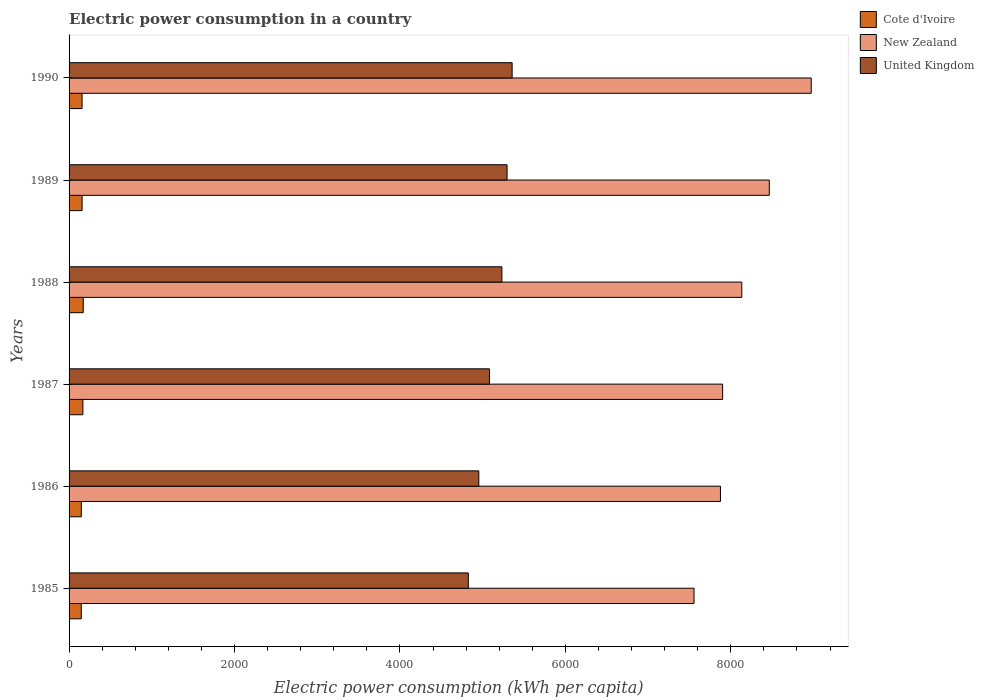How many groups of bars are there?
Offer a terse response. 6. How many bars are there on the 6th tick from the top?
Ensure brevity in your answer.  3. What is the electric power consumption in in United Kingdom in 1987?
Your answer should be compact. 5082.44. Across all years, what is the maximum electric power consumption in in New Zealand?
Your answer should be compact. 8972.31. Across all years, what is the minimum electric power consumption in in United Kingdom?
Ensure brevity in your answer.  4826.71. What is the total electric power consumption in in New Zealand in the graph?
Your answer should be very brief. 4.89e+04. What is the difference between the electric power consumption in in United Kingdom in 1985 and that in 1990?
Offer a terse response. -529.86. What is the difference between the electric power consumption in in New Zealand in 1987 and the electric power consumption in in United Kingdom in 1986?
Make the answer very short. 2947.64. What is the average electric power consumption in in United Kingdom per year?
Your answer should be compact. 5124.56. In the year 1985, what is the difference between the electric power consumption in in New Zealand and electric power consumption in in United Kingdom?
Your answer should be compact. 2728.95. What is the ratio of the electric power consumption in in New Zealand in 1986 to that in 1987?
Your response must be concise. 1. Is the electric power consumption in in Cote d'Ivoire in 1987 less than that in 1990?
Provide a succinct answer. No. What is the difference between the highest and the second highest electric power consumption in in United Kingdom?
Your answer should be very brief. 61.35. What is the difference between the highest and the lowest electric power consumption in in Cote d'Ivoire?
Give a very brief answer. 23.64. In how many years, is the electric power consumption in in United Kingdom greater than the average electric power consumption in in United Kingdom taken over all years?
Ensure brevity in your answer.  3. What does the 3rd bar from the top in 1990 represents?
Make the answer very short. Cote d'Ivoire. Is it the case that in every year, the sum of the electric power consumption in in United Kingdom and electric power consumption in in New Zealand is greater than the electric power consumption in in Cote d'Ivoire?
Provide a succinct answer. Yes. Are the values on the major ticks of X-axis written in scientific E-notation?
Provide a succinct answer. No. Does the graph contain any zero values?
Offer a very short reply. No. Does the graph contain grids?
Your answer should be very brief. No. Where does the legend appear in the graph?
Offer a terse response. Top right. How many legend labels are there?
Offer a terse response. 3. How are the legend labels stacked?
Ensure brevity in your answer.  Vertical. What is the title of the graph?
Give a very brief answer. Electric power consumption in a country. What is the label or title of the X-axis?
Keep it short and to the point. Electric power consumption (kWh per capita). What is the label or title of the Y-axis?
Your answer should be very brief. Years. What is the Electric power consumption (kWh per capita) of Cote d'Ivoire in 1985?
Keep it short and to the point. 147.57. What is the Electric power consumption (kWh per capita) of New Zealand in 1985?
Your response must be concise. 7555.67. What is the Electric power consumption (kWh per capita) of United Kingdom in 1985?
Provide a short and direct response. 4826.71. What is the Electric power consumption (kWh per capita) in Cote d'Ivoire in 1986?
Give a very brief answer. 148.18. What is the Electric power consumption (kWh per capita) of New Zealand in 1986?
Your response must be concise. 7875.12. What is the Electric power consumption (kWh per capita) in United Kingdom in 1986?
Offer a very short reply. 4953.65. What is the Electric power consumption (kWh per capita) of Cote d'Ivoire in 1987?
Provide a short and direct response. 166.82. What is the Electric power consumption (kWh per capita) in New Zealand in 1987?
Make the answer very short. 7901.29. What is the Electric power consumption (kWh per capita) in United Kingdom in 1987?
Provide a short and direct response. 5082.44. What is the Electric power consumption (kWh per capita) of Cote d'Ivoire in 1988?
Offer a terse response. 171.21. What is the Electric power consumption (kWh per capita) in New Zealand in 1988?
Provide a short and direct response. 8133.03. What is the Electric power consumption (kWh per capita) of United Kingdom in 1988?
Your response must be concise. 5232.74. What is the Electric power consumption (kWh per capita) in Cote d'Ivoire in 1989?
Make the answer very short. 157.43. What is the Electric power consumption (kWh per capita) of New Zealand in 1989?
Make the answer very short. 8465.39. What is the Electric power consumption (kWh per capita) of United Kingdom in 1989?
Keep it short and to the point. 5295.22. What is the Electric power consumption (kWh per capita) of Cote d'Ivoire in 1990?
Offer a terse response. 157.24. What is the Electric power consumption (kWh per capita) in New Zealand in 1990?
Give a very brief answer. 8972.31. What is the Electric power consumption (kWh per capita) of United Kingdom in 1990?
Make the answer very short. 5356.58. Across all years, what is the maximum Electric power consumption (kWh per capita) of Cote d'Ivoire?
Make the answer very short. 171.21. Across all years, what is the maximum Electric power consumption (kWh per capita) of New Zealand?
Offer a terse response. 8972.31. Across all years, what is the maximum Electric power consumption (kWh per capita) in United Kingdom?
Give a very brief answer. 5356.58. Across all years, what is the minimum Electric power consumption (kWh per capita) in Cote d'Ivoire?
Give a very brief answer. 147.57. Across all years, what is the minimum Electric power consumption (kWh per capita) of New Zealand?
Offer a terse response. 7555.67. Across all years, what is the minimum Electric power consumption (kWh per capita) of United Kingdom?
Provide a short and direct response. 4826.71. What is the total Electric power consumption (kWh per capita) in Cote d'Ivoire in the graph?
Keep it short and to the point. 948.45. What is the total Electric power consumption (kWh per capita) of New Zealand in the graph?
Ensure brevity in your answer.  4.89e+04. What is the total Electric power consumption (kWh per capita) in United Kingdom in the graph?
Ensure brevity in your answer.  3.07e+04. What is the difference between the Electric power consumption (kWh per capita) of Cote d'Ivoire in 1985 and that in 1986?
Provide a succinct answer. -0.61. What is the difference between the Electric power consumption (kWh per capita) in New Zealand in 1985 and that in 1986?
Offer a very short reply. -319.45. What is the difference between the Electric power consumption (kWh per capita) of United Kingdom in 1985 and that in 1986?
Keep it short and to the point. -126.94. What is the difference between the Electric power consumption (kWh per capita) in Cote d'Ivoire in 1985 and that in 1987?
Make the answer very short. -19.25. What is the difference between the Electric power consumption (kWh per capita) in New Zealand in 1985 and that in 1987?
Your response must be concise. -345.63. What is the difference between the Electric power consumption (kWh per capita) of United Kingdom in 1985 and that in 1987?
Make the answer very short. -255.73. What is the difference between the Electric power consumption (kWh per capita) in Cote d'Ivoire in 1985 and that in 1988?
Offer a terse response. -23.64. What is the difference between the Electric power consumption (kWh per capita) of New Zealand in 1985 and that in 1988?
Provide a short and direct response. -577.37. What is the difference between the Electric power consumption (kWh per capita) in United Kingdom in 1985 and that in 1988?
Make the answer very short. -406.02. What is the difference between the Electric power consumption (kWh per capita) in Cote d'Ivoire in 1985 and that in 1989?
Your answer should be very brief. -9.86. What is the difference between the Electric power consumption (kWh per capita) of New Zealand in 1985 and that in 1989?
Provide a short and direct response. -909.72. What is the difference between the Electric power consumption (kWh per capita) in United Kingdom in 1985 and that in 1989?
Your response must be concise. -468.51. What is the difference between the Electric power consumption (kWh per capita) of Cote d'Ivoire in 1985 and that in 1990?
Keep it short and to the point. -9.67. What is the difference between the Electric power consumption (kWh per capita) of New Zealand in 1985 and that in 1990?
Give a very brief answer. -1416.65. What is the difference between the Electric power consumption (kWh per capita) of United Kingdom in 1985 and that in 1990?
Your answer should be compact. -529.86. What is the difference between the Electric power consumption (kWh per capita) of Cote d'Ivoire in 1986 and that in 1987?
Ensure brevity in your answer.  -18.64. What is the difference between the Electric power consumption (kWh per capita) of New Zealand in 1986 and that in 1987?
Your response must be concise. -26.18. What is the difference between the Electric power consumption (kWh per capita) in United Kingdom in 1986 and that in 1987?
Give a very brief answer. -128.79. What is the difference between the Electric power consumption (kWh per capita) of Cote d'Ivoire in 1986 and that in 1988?
Give a very brief answer. -23.03. What is the difference between the Electric power consumption (kWh per capita) of New Zealand in 1986 and that in 1988?
Provide a succinct answer. -257.91. What is the difference between the Electric power consumption (kWh per capita) of United Kingdom in 1986 and that in 1988?
Give a very brief answer. -279.08. What is the difference between the Electric power consumption (kWh per capita) in Cote d'Ivoire in 1986 and that in 1989?
Offer a terse response. -9.26. What is the difference between the Electric power consumption (kWh per capita) of New Zealand in 1986 and that in 1989?
Your answer should be compact. -590.27. What is the difference between the Electric power consumption (kWh per capita) in United Kingdom in 1986 and that in 1989?
Your answer should be very brief. -341.57. What is the difference between the Electric power consumption (kWh per capita) in Cote d'Ivoire in 1986 and that in 1990?
Provide a short and direct response. -9.06. What is the difference between the Electric power consumption (kWh per capita) in New Zealand in 1986 and that in 1990?
Keep it short and to the point. -1097.19. What is the difference between the Electric power consumption (kWh per capita) in United Kingdom in 1986 and that in 1990?
Ensure brevity in your answer.  -402.92. What is the difference between the Electric power consumption (kWh per capita) in Cote d'Ivoire in 1987 and that in 1988?
Provide a succinct answer. -4.39. What is the difference between the Electric power consumption (kWh per capita) of New Zealand in 1987 and that in 1988?
Make the answer very short. -231.74. What is the difference between the Electric power consumption (kWh per capita) in United Kingdom in 1987 and that in 1988?
Your answer should be compact. -150.3. What is the difference between the Electric power consumption (kWh per capita) of Cote d'Ivoire in 1987 and that in 1989?
Give a very brief answer. 9.39. What is the difference between the Electric power consumption (kWh per capita) in New Zealand in 1987 and that in 1989?
Offer a terse response. -564.09. What is the difference between the Electric power consumption (kWh per capita) in United Kingdom in 1987 and that in 1989?
Make the answer very short. -212.78. What is the difference between the Electric power consumption (kWh per capita) in Cote d'Ivoire in 1987 and that in 1990?
Your answer should be very brief. 9.58. What is the difference between the Electric power consumption (kWh per capita) in New Zealand in 1987 and that in 1990?
Provide a short and direct response. -1071.02. What is the difference between the Electric power consumption (kWh per capita) in United Kingdom in 1987 and that in 1990?
Make the answer very short. -274.14. What is the difference between the Electric power consumption (kWh per capita) of Cote d'Ivoire in 1988 and that in 1989?
Keep it short and to the point. 13.77. What is the difference between the Electric power consumption (kWh per capita) of New Zealand in 1988 and that in 1989?
Make the answer very short. -332.35. What is the difference between the Electric power consumption (kWh per capita) in United Kingdom in 1988 and that in 1989?
Your answer should be compact. -62.49. What is the difference between the Electric power consumption (kWh per capita) of Cote d'Ivoire in 1988 and that in 1990?
Provide a short and direct response. 13.96. What is the difference between the Electric power consumption (kWh per capita) of New Zealand in 1988 and that in 1990?
Offer a terse response. -839.28. What is the difference between the Electric power consumption (kWh per capita) in United Kingdom in 1988 and that in 1990?
Ensure brevity in your answer.  -123.84. What is the difference between the Electric power consumption (kWh per capita) of Cote d'Ivoire in 1989 and that in 1990?
Make the answer very short. 0.19. What is the difference between the Electric power consumption (kWh per capita) of New Zealand in 1989 and that in 1990?
Make the answer very short. -506.93. What is the difference between the Electric power consumption (kWh per capita) in United Kingdom in 1989 and that in 1990?
Keep it short and to the point. -61.35. What is the difference between the Electric power consumption (kWh per capita) of Cote d'Ivoire in 1985 and the Electric power consumption (kWh per capita) of New Zealand in 1986?
Your answer should be very brief. -7727.55. What is the difference between the Electric power consumption (kWh per capita) of Cote d'Ivoire in 1985 and the Electric power consumption (kWh per capita) of United Kingdom in 1986?
Provide a short and direct response. -4806.09. What is the difference between the Electric power consumption (kWh per capita) in New Zealand in 1985 and the Electric power consumption (kWh per capita) in United Kingdom in 1986?
Your response must be concise. 2602.01. What is the difference between the Electric power consumption (kWh per capita) in Cote d'Ivoire in 1985 and the Electric power consumption (kWh per capita) in New Zealand in 1987?
Provide a succinct answer. -7753.73. What is the difference between the Electric power consumption (kWh per capita) in Cote d'Ivoire in 1985 and the Electric power consumption (kWh per capita) in United Kingdom in 1987?
Your answer should be very brief. -4934.87. What is the difference between the Electric power consumption (kWh per capita) in New Zealand in 1985 and the Electric power consumption (kWh per capita) in United Kingdom in 1987?
Give a very brief answer. 2473.23. What is the difference between the Electric power consumption (kWh per capita) of Cote d'Ivoire in 1985 and the Electric power consumption (kWh per capita) of New Zealand in 1988?
Offer a very short reply. -7985.46. What is the difference between the Electric power consumption (kWh per capita) in Cote d'Ivoire in 1985 and the Electric power consumption (kWh per capita) in United Kingdom in 1988?
Your response must be concise. -5085.17. What is the difference between the Electric power consumption (kWh per capita) in New Zealand in 1985 and the Electric power consumption (kWh per capita) in United Kingdom in 1988?
Your answer should be compact. 2322.93. What is the difference between the Electric power consumption (kWh per capita) in Cote d'Ivoire in 1985 and the Electric power consumption (kWh per capita) in New Zealand in 1989?
Keep it short and to the point. -8317.82. What is the difference between the Electric power consumption (kWh per capita) in Cote d'Ivoire in 1985 and the Electric power consumption (kWh per capita) in United Kingdom in 1989?
Offer a terse response. -5147.66. What is the difference between the Electric power consumption (kWh per capita) in New Zealand in 1985 and the Electric power consumption (kWh per capita) in United Kingdom in 1989?
Offer a very short reply. 2260.44. What is the difference between the Electric power consumption (kWh per capita) in Cote d'Ivoire in 1985 and the Electric power consumption (kWh per capita) in New Zealand in 1990?
Make the answer very short. -8824.74. What is the difference between the Electric power consumption (kWh per capita) in Cote d'Ivoire in 1985 and the Electric power consumption (kWh per capita) in United Kingdom in 1990?
Provide a succinct answer. -5209.01. What is the difference between the Electric power consumption (kWh per capita) in New Zealand in 1985 and the Electric power consumption (kWh per capita) in United Kingdom in 1990?
Your answer should be very brief. 2199.09. What is the difference between the Electric power consumption (kWh per capita) of Cote d'Ivoire in 1986 and the Electric power consumption (kWh per capita) of New Zealand in 1987?
Provide a succinct answer. -7753.12. What is the difference between the Electric power consumption (kWh per capita) in Cote d'Ivoire in 1986 and the Electric power consumption (kWh per capita) in United Kingdom in 1987?
Provide a succinct answer. -4934.26. What is the difference between the Electric power consumption (kWh per capita) in New Zealand in 1986 and the Electric power consumption (kWh per capita) in United Kingdom in 1987?
Offer a terse response. 2792.68. What is the difference between the Electric power consumption (kWh per capita) of Cote d'Ivoire in 1986 and the Electric power consumption (kWh per capita) of New Zealand in 1988?
Give a very brief answer. -7984.86. What is the difference between the Electric power consumption (kWh per capita) of Cote d'Ivoire in 1986 and the Electric power consumption (kWh per capita) of United Kingdom in 1988?
Provide a short and direct response. -5084.56. What is the difference between the Electric power consumption (kWh per capita) of New Zealand in 1986 and the Electric power consumption (kWh per capita) of United Kingdom in 1988?
Your answer should be very brief. 2642.38. What is the difference between the Electric power consumption (kWh per capita) of Cote d'Ivoire in 1986 and the Electric power consumption (kWh per capita) of New Zealand in 1989?
Your answer should be very brief. -8317.21. What is the difference between the Electric power consumption (kWh per capita) of Cote d'Ivoire in 1986 and the Electric power consumption (kWh per capita) of United Kingdom in 1989?
Give a very brief answer. -5147.05. What is the difference between the Electric power consumption (kWh per capita) in New Zealand in 1986 and the Electric power consumption (kWh per capita) in United Kingdom in 1989?
Offer a terse response. 2579.89. What is the difference between the Electric power consumption (kWh per capita) of Cote d'Ivoire in 1986 and the Electric power consumption (kWh per capita) of New Zealand in 1990?
Your response must be concise. -8824.13. What is the difference between the Electric power consumption (kWh per capita) of Cote d'Ivoire in 1986 and the Electric power consumption (kWh per capita) of United Kingdom in 1990?
Offer a terse response. -5208.4. What is the difference between the Electric power consumption (kWh per capita) of New Zealand in 1986 and the Electric power consumption (kWh per capita) of United Kingdom in 1990?
Keep it short and to the point. 2518.54. What is the difference between the Electric power consumption (kWh per capita) in Cote d'Ivoire in 1987 and the Electric power consumption (kWh per capita) in New Zealand in 1988?
Keep it short and to the point. -7966.21. What is the difference between the Electric power consumption (kWh per capita) of Cote d'Ivoire in 1987 and the Electric power consumption (kWh per capita) of United Kingdom in 1988?
Your answer should be very brief. -5065.92. What is the difference between the Electric power consumption (kWh per capita) in New Zealand in 1987 and the Electric power consumption (kWh per capita) in United Kingdom in 1988?
Your answer should be compact. 2668.56. What is the difference between the Electric power consumption (kWh per capita) in Cote d'Ivoire in 1987 and the Electric power consumption (kWh per capita) in New Zealand in 1989?
Ensure brevity in your answer.  -8298.57. What is the difference between the Electric power consumption (kWh per capita) in Cote d'Ivoire in 1987 and the Electric power consumption (kWh per capita) in United Kingdom in 1989?
Make the answer very short. -5128.41. What is the difference between the Electric power consumption (kWh per capita) of New Zealand in 1987 and the Electric power consumption (kWh per capita) of United Kingdom in 1989?
Ensure brevity in your answer.  2606.07. What is the difference between the Electric power consumption (kWh per capita) of Cote d'Ivoire in 1987 and the Electric power consumption (kWh per capita) of New Zealand in 1990?
Your response must be concise. -8805.49. What is the difference between the Electric power consumption (kWh per capita) in Cote d'Ivoire in 1987 and the Electric power consumption (kWh per capita) in United Kingdom in 1990?
Offer a terse response. -5189.76. What is the difference between the Electric power consumption (kWh per capita) of New Zealand in 1987 and the Electric power consumption (kWh per capita) of United Kingdom in 1990?
Your response must be concise. 2544.72. What is the difference between the Electric power consumption (kWh per capita) in Cote d'Ivoire in 1988 and the Electric power consumption (kWh per capita) in New Zealand in 1989?
Keep it short and to the point. -8294.18. What is the difference between the Electric power consumption (kWh per capita) in Cote d'Ivoire in 1988 and the Electric power consumption (kWh per capita) in United Kingdom in 1989?
Make the answer very short. -5124.02. What is the difference between the Electric power consumption (kWh per capita) in New Zealand in 1988 and the Electric power consumption (kWh per capita) in United Kingdom in 1989?
Ensure brevity in your answer.  2837.81. What is the difference between the Electric power consumption (kWh per capita) in Cote d'Ivoire in 1988 and the Electric power consumption (kWh per capita) in New Zealand in 1990?
Offer a terse response. -8801.1. What is the difference between the Electric power consumption (kWh per capita) in Cote d'Ivoire in 1988 and the Electric power consumption (kWh per capita) in United Kingdom in 1990?
Ensure brevity in your answer.  -5185.37. What is the difference between the Electric power consumption (kWh per capita) in New Zealand in 1988 and the Electric power consumption (kWh per capita) in United Kingdom in 1990?
Provide a short and direct response. 2776.46. What is the difference between the Electric power consumption (kWh per capita) of Cote d'Ivoire in 1989 and the Electric power consumption (kWh per capita) of New Zealand in 1990?
Your answer should be compact. -8814.88. What is the difference between the Electric power consumption (kWh per capita) in Cote d'Ivoire in 1989 and the Electric power consumption (kWh per capita) in United Kingdom in 1990?
Your answer should be compact. -5199.14. What is the difference between the Electric power consumption (kWh per capita) of New Zealand in 1989 and the Electric power consumption (kWh per capita) of United Kingdom in 1990?
Your answer should be very brief. 3108.81. What is the average Electric power consumption (kWh per capita) of Cote d'Ivoire per year?
Keep it short and to the point. 158.07. What is the average Electric power consumption (kWh per capita) of New Zealand per year?
Make the answer very short. 8150.47. What is the average Electric power consumption (kWh per capita) of United Kingdom per year?
Offer a terse response. 5124.56. In the year 1985, what is the difference between the Electric power consumption (kWh per capita) in Cote d'Ivoire and Electric power consumption (kWh per capita) in New Zealand?
Provide a succinct answer. -7408.1. In the year 1985, what is the difference between the Electric power consumption (kWh per capita) of Cote d'Ivoire and Electric power consumption (kWh per capita) of United Kingdom?
Offer a very short reply. -4679.15. In the year 1985, what is the difference between the Electric power consumption (kWh per capita) in New Zealand and Electric power consumption (kWh per capita) in United Kingdom?
Offer a very short reply. 2728.95. In the year 1986, what is the difference between the Electric power consumption (kWh per capita) of Cote d'Ivoire and Electric power consumption (kWh per capita) of New Zealand?
Offer a very short reply. -7726.94. In the year 1986, what is the difference between the Electric power consumption (kWh per capita) of Cote d'Ivoire and Electric power consumption (kWh per capita) of United Kingdom?
Keep it short and to the point. -4805.48. In the year 1986, what is the difference between the Electric power consumption (kWh per capita) of New Zealand and Electric power consumption (kWh per capita) of United Kingdom?
Make the answer very short. 2921.47. In the year 1987, what is the difference between the Electric power consumption (kWh per capita) in Cote d'Ivoire and Electric power consumption (kWh per capita) in New Zealand?
Make the answer very short. -7734.48. In the year 1987, what is the difference between the Electric power consumption (kWh per capita) in Cote d'Ivoire and Electric power consumption (kWh per capita) in United Kingdom?
Provide a short and direct response. -4915.62. In the year 1987, what is the difference between the Electric power consumption (kWh per capita) in New Zealand and Electric power consumption (kWh per capita) in United Kingdom?
Make the answer very short. 2818.86. In the year 1988, what is the difference between the Electric power consumption (kWh per capita) in Cote d'Ivoire and Electric power consumption (kWh per capita) in New Zealand?
Provide a short and direct response. -7961.83. In the year 1988, what is the difference between the Electric power consumption (kWh per capita) of Cote d'Ivoire and Electric power consumption (kWh per capita) of United Kingdom?
Give a very brief answer. -5061.53. In the year 1988, what is the difference between the Electric power consumption (kWh per capita) in New Zealand and Electric power consumption (kWh per capita) in United Kingdom?
Offer a terse response. 2900.3. In the year 1989, what is the difference between the Electric power consumption (kWh per capita) of Cote d'Ivoire and Electric power consumption (kWh per capita) of New Zealand?
Your answer should be compact. -8307.95. In the year 1989, what is the difference between the Electric power consumption (kWh per capita) in Cote d'Ivoire and Electric power consumption (kWh per capita) in United Kingdom?
Offer a terse response. -5137.79. In the year 1989, what is the difference between the Electric power consumption (kWh per capita) in New Zealand and Electric power consumption (kWh per capita) in United Kingdom?
Provide a short and direct response. 3170.16. In the year 1990, what is the difference between the Electric power consumption (kWh per capita) of Cote d'Ivoire and Electric power consumption (kWh per capita) of New Zealand?
Provide a succinct answer. -8815.07. In the year 1990, what is the difference between the Electric power consumption (kWh per capita) in Cote d'Ivoire and Electric power consumption (kWh per capita) in United Kingdom?
Your response must be concise. -5199.33. In the year 1990, what is the difference between the Electric power consumption (kWh per capita) of New Zealand and Electric power consumption (kWh per capita) of United Kingdom?
Your answer should be compact. 3615.74. What is the ratio of the Electric power consumption (kWh per capita) in New Zealand in 1985 to that in 1986?
Provide a short and direct response. 0.96. What is the ratio of the Electric power consumption (kWh per capita) of United Kingdom in 1985 to that in 1986?
Provide a short and direct response. 0.97. What is the ratio of the Electric power consumption (kWh per capita) in Cote d'Ivoire in 1985 to that in 1987?
Provide a succinct answer. 0.88. What is the ratio of the Electric power consumption (kWh per capita) in New Zealand in 1985 to that in 1987?
Your answer should be very brief. 0.96. What is the ratio of the Electric power consumption (kWh per capita) of United Kingdom in 1985 to that in 1987?
Provide a succinct answer. 0.95. What is the ratio of the Electric power consumption (kWh per capita) in Cote d'Ivoire in 1985 to that in 1988?
Offer a terse response. 0.86. What is the ratio of the Electric power consumption (kWh per capita) in New Zealand in 1985 to that in 1988?
Your response must be concise. 0.93. What is the ratio of the Electric power consumption (kWh per capita) of United Kingdom in 1985 to that in 1988?
Provide a short and direct response. 0.92. What is the ratio of the Electric power consumption (kWh per capita) in Cote d'Ivoire in 1985 to that in 1989?
Ensure brevity in your answer.  0.94. What is the ratio of the Electric power consumption (kWh per capita) in New Zealand in 1985 to that in 1989?
Your answer should be very brief. 0.89. What is the ratio of the Electric power consumption (kWh per capita) of United Kingdom in 1985 to that in 1989?
Your answer should be compact. 0.91. What is the ratio of the Electric power consumption (kWh per capita) of Cote d'Ivoire in 1985 to that in 1990?
Your answer should be very brief. 0.94. What is the ratio of the Electric power consumption (kWh per capita) in New Zealand in 1985 to that in 1990?
Your answer should be compact. 0.84. What is the ratio of the Electric power consumption (kWh per capita) of United Kingdom in 1985 to that in 1990?
Your answer should be compact. 0.9. What is the ratio of the Electric power consumption (kWh per capita) in Cote d'Ivoire in 1986 to that in 1987?
Your response must be concise. 0.89. What is the ratio of the Electric power consumption (kWh per capita) in United Kingdom in 1986 to that in 1987?
Provide a short and direct response. 0.97. What is the ratio of the Electric power consumption (kWh per capita) of Cote d'Ivoire in 1986 to that in 1988?
Provide a short and direct response. 0.87. What is the ratio of the Electric power consumption (kWh per capita) of New Zealand in 1986 to that in 1988?
Your answer should be very brief. 0.97. What is the ratio of the Electric power consumption (kWh per capita) in United Kingdom in 1986 to that in 1988?
Provide a succinct answer. 0.95. What is the ratio of the Electric power consumption (kWh per capita) of New Zealand in 1986 to that in 1989?
Keep it short and to the point. 0.93. What is the ratio of the Electric power consumption (kWh per capita) in United Kingdom in 1986 to that in 1989?
Provide a succinct answer. 0.94. What is the ratio of the Electric power consumption (kWh per capita) of Cote d'Ivoire in 1986 to that in 1990?
Your response must be concise. 0.94. What is the ratio of the Electric power consumption (kWh per capita) in New Zealand in 1986 to that in 1990?
Provide a short and direct response. 0.88. What is the ratio of the Electric power consumption (kWh per capita) of United Kingdom in 1986 to that in 1990?
Give a very brief answer. 0.92. What is the ratio of the Electric power consumption (kWh per capita) of Cote d'Ivoire in 1987 to that in 1988?
Ensure brevity in your answer.  0.97. What is the ratio of the Electric power consumption (kWh per capita) in New Zealand in 1987 to that in 1988?
Your response must be concise. 0.97. What is the ratio of the Electric power consumption (kWh per capita) in United Kingdom in 1987 to that in 1988?
Your answer should be compact. 0.97. What is the ratio of the Electric power consumption (kWh per capita) of Cote d'Ivoire in 1987 to that in 1989?
Provide a succinct answer. 1.06. What is the ratio of the Electric power consumption (kWh per capita) in New Zealand in 1987 to that in 1989?
Offer a terse response. 0.93. What is the ratio of the Electric power consumption (kWh per capita) of United Kingdom in 1987 to that in 1989?
Offer a terse response. 0.96. What is the ratio of the Electric power consumption (kWh per capita) of Cote d'Ivoire in 1987 to that in 1990?
Your answer should be compact. 1.06. What is the ratio of the Electric power consumption (kWh per capita) in New Zealand in 1987 to that in 1990?
Offer a terse response. 0.88. What is the ratio of the Electric power consumption (kWh per capita) in United Kingdom in 1987 to that in 1990?
Offer a very short reply. 0.95. What is the ratio of the Electric power consumption (kWh per capita) of Cote d'Ivoire in 1988 to that in 1989?
Provide a succinct answer. 1.09. What is the ratio of the Electric power consumption (kWh per capita) in New Zealand in 1988 to that in 1989?
Offer a very short reply. 0.96. What is the ratio of the Electric power consumption (kWh per capita) of Cote d'Ivoire in 1988 to that in 1990?
Give a very brief answer. 1.09. What is the ratio of the Electric power consumption (kWh per capita) in New Zealand in 1988 to that in 1990?
Provide a short and direct response. 0.91. What is the ratio of the Electric power consumption (kWh per capita) in United Kingdom in 1988 to that in 1990?
Offer a terse response. 0.98. What is the ratio of the Electric power consumption (kWh per capita) of Cote d'Ivoire in 1989 to that in 1990?
Your answer should be compact. 1. What is the ratio of the Electric power consumption (kWh per capita) of New Zealand in 1989 to that in 1990?
Make the answer very short. 0.94. What is the difference between the highest and the second highest Electric power consumption (kWh per capita) of Cote d'Ivoire?
Your answer should be compact. 4.39. What is the difference between the highest and the second highest Electric power consumption (kWh per capita) in New Zealand?
Make the answer very short. 506.93. What is the difference between the highest and the second highest Electric power consumption (kWh per capita) in United Kingdom?
Keep it short and to the point. 61.35. What is the difference between the highest and the lowest Electric power consumption (kWh per capita) of Cote d'Ivoire?
Your response must be concise. 23.64. What is the difference between the highest and the lowest Electric power consumption (kWh per capita) of New Zealand?
Provide a succinct answer. 1416.65. What is the difference between the highest and the lowest Electric power consumption (kWh per capita) in United Kingdom?
Offer a terse response. 529.86. 